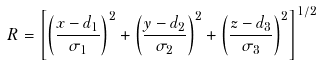Convert formula to latex. <formula><loc_0><loc_0><loc_500><loc_500>R = \left [ \left ( \frac { x - d _ { 1 } } { \sigma _ { 1 } } \right ) ^ { 2 } + \left ( \frac { y - d _ { 2 } } { \sigma _ { 2 } } \right ) ^ { 2 } + \left ( \frac { z - d _ { 3 } } { \sigma _ { 3 } } \right ) ^ { 2 } \right ] ^ { 1 / 2 }</formula> 